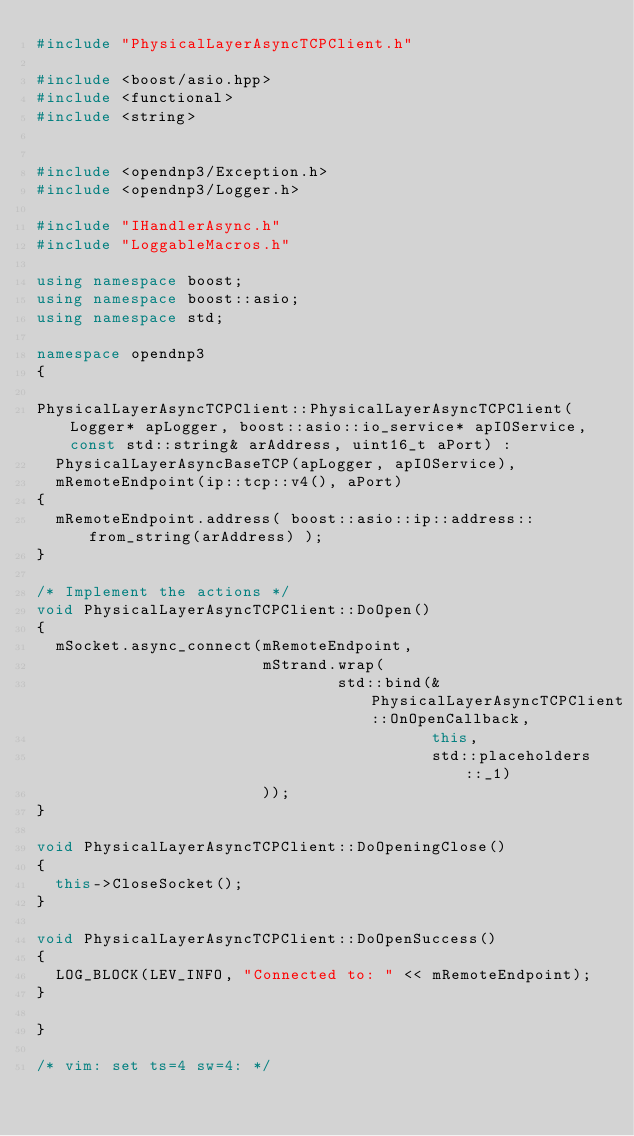Convert code to text. <code><loc_0><loc_0><loc_500><loc_500><_C++_>#include "PhysicalLayerAsyncTCPClient.h"

#include <boost/asio.hpp>
#include <functional>
#include <string>


#include <opendnp3/Exception.h>
#include <opendnp3/Logger.h>

#include "IHandlerAsync.h"
#include "LoggableMacros.h"

using namespace boost;
using namespace boost::asio;
using namespace std;

namespace opendnp3
{

PhysicalLayerAsyncTCPClient::PhysicalLayerAsyncTCPClient(Logger* apLogger, boost::asio::io_service* apIOService, const std::string& arAddress, uint16_t aPort) :
	PhysicalLayerAsyncBaseTCP(apLogger, apIOService),
	mRemoteEndpoint(ip::tcp::v4(), aPort)
{
	mRemoteEndpoint.address( boost::asio::ip::address::from_string(arAddress) );
}

/* Implement the actions */
void PhysicalLayerAsyncTCPClient::DoOpen()
{
	mSocket.async_connect(mRemoteEndpoint,
	                      mStrand.wrap(
	                              std::bind(&PhysicalLayerAsyncTCPClient::OnOpenCallback,
	                                        this,
	                                        std::placeholders::_1)
	                      ));
}

void PhysicalLayerAsyncTCPClient::DoOpeningClose()
{
	this->CloseSocket();
}

void PhysicalLayerAsyncTCPClient::DoOpenSuccess()
{
	LOG_BLOCK(LEV_INFO, "Connected to: " << mRemoteEndpoint);
}

}

/* vim: set ts=4 sw=4: */
</code> 